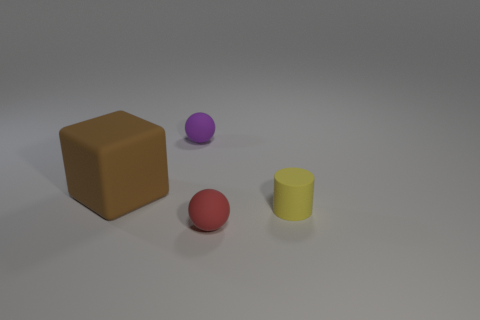What shape is the tiny matte object that is to the right of the tiny ball on the right side of the ball that is left of the small red object? cylinder 